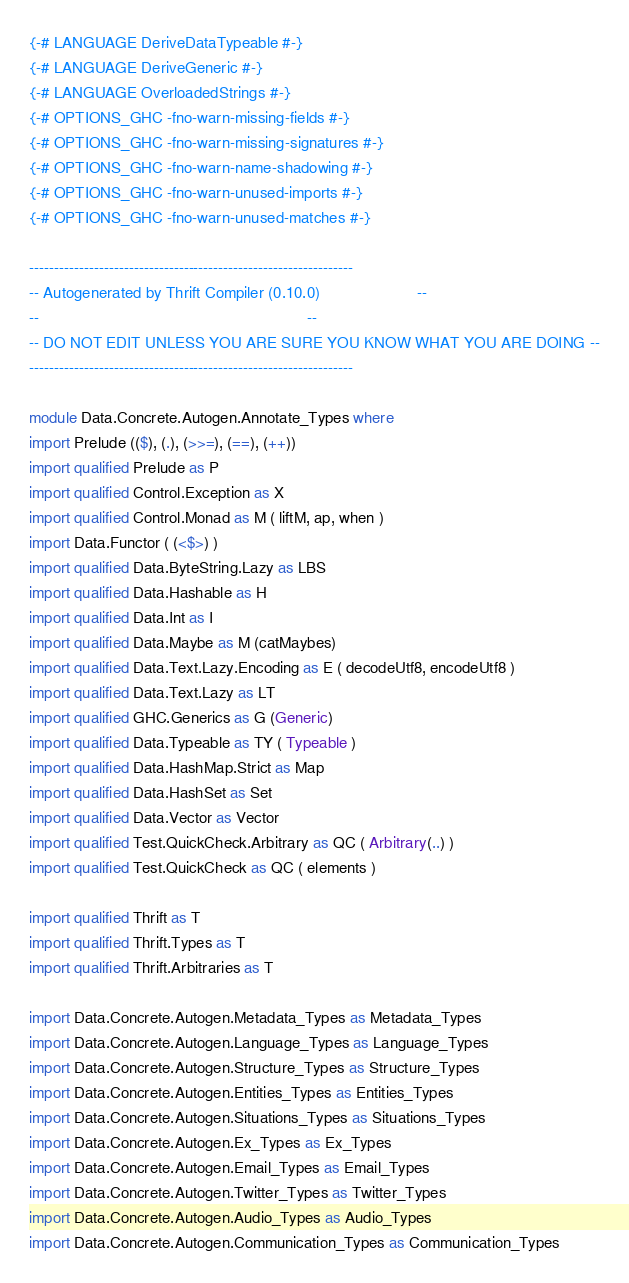Convert code to text. <code><loc_0><loc_0><loc_500><loc_500><_Haskell_>{-# LANGUAGE DeriveDataTypeable #-}
{-# LANGUAGE DeriveGeneric #-}
{-# LANGUAGE OverloadedStrings #-}
{-# OPTIONS_GHC -fno-warn-missing-fields #-}
{-# OPTIONS_GHC -fno-warn-missing-signatures #-}
{-# OPTIONS_GHC -fno-warn-name-shadowing #-}
{-# OPTIONS_GHC -fno-warn-unused-imports #-}
{-# OPTIONS_GHC -fno-warn-unused-matches #-}

-----------------------------------------------------------------
-- Autogenerated by Thrift Compiler (0.10.0)                      --
--                                                             --
-- DO NOT EDIT UNLESS YOU ARE SURE YOU KNOW WHAT YOU ARE DOING --
-----------------------------------------------------------------

module Data.Concrete.Autogen.Annotate_Types where
import Prelude (($), (.), (>>=), (==), (++))
import qualified Prelude as P
import qualified Control.Exception as X
import qualified Control.Monad as M ( liftM, ap, when )
import Data.Functor ( (<$>) )
import qualified Data.ByteString.Lazy as LBS
import qualified Data.Hashable as H
import qualified Data.Int as I
import qualified Data.Maybe as M (catMaybes)
import qualified Data.Text.Lazy.Encoding as E ( decodeUtf8, encodeUtf8 )
import qualified Data.Text.Lazy as LT
import qualified GHC.Generics as G (Generic)
import qualified Data.Typeable as TY ( Typeable )
import qualified Data.HashMap.Strict as Map
import qualified Data.HashSet as Set
import qualified Data.Vector as Vector
import qualified Test.QuickCheck.Arbitrary as QC ( Arbitrary(..) )
import qualified Test.QuickCheck as QC ( elements )

import qualified Thrift as T
import qualified Thrift.Types as T
import qualified Thrift.Arbitraries as T

import Data.Concrete.Autogen.Metadata_Types as Metadata_Types
import Data.Concrete.Autogen.Language_Types as Language_Types
import Data.Concrete.Autogen.Structure_Types as Structure_Types
import Data.Concrete.Autogen.Entities_Types as Entities_Types
import Data.Concrete.Autogen.Situations_Types as Situations_Types
import Data.Concrete.Autogen.Ex_Types as Ex_Types
import Data.Concrete.Autogen.Email_Types as Email_Types
import Data.Concrete.Autogen.Twitter_Types as Twitter_Types
import Data.Concrete.Autogen.Audio_Types as Audio_Types
import Data.Concrete.Autogen.Communication_Types as Communication_Types


</code> 